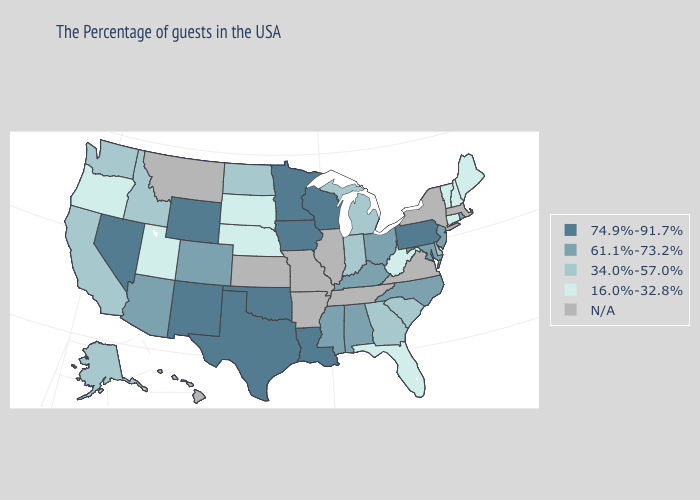Name the states that have a value in the range 61.1%-73.2%?
Answer briefly. Rhode Island, New Jersey, Maryland, North Carolina, Ohio, Kentucky, Alabama, Mississippi, Colorado, Arizona. Name the states that have a value in the range N/A?
Keep it brief. Massachusetts, New York, Virginia, Tennessee, Illinois, Missouri, Arkansas, Kansas, Montana, Hawaii. Does the first symbol in the legend represent the smallest category?
Write a very short answer. No. Does Idaho have the highest value in the West?
Give a very brief answer. No. Name the states that have a value in the range 61.1%-73.2%?
Keep it brief. Rhode Island, New Jersey, Maryland, North Carolina, Ohio, Kentucky, Alabama, Mississippi, Colorado, Arizona. Name the states that have a value in the range N/A?
Quick response, please. Massachusetts, New York, Virginia, Tennessee, Illinois, Missouri, Arkansas, Kansas, Montana, Hawaii. How many symbols are there in the legend?
Write a very short answer. 5. Which states have the lowest value in the USA?
Be succinct. Maine, New Hampshire, Vermont, Connecticut, West Virginia, Florida, Nebraska, South Dakota, Utah, Oregon. Does the map have missing data?
Give a very brief answer. Yes. Name the states that have a value in the range 74.9%-91.7%?
Quick response, please. Pennsylvania, Wisconsin, Louisiana, Minnesota, Iowa, Oklahoma, Texas, Wyoming, New Mexico, Nevada. Name the states that have a value in the range 34.0%-57.0%?
Keep it brief. Delaware, South Carolina, Georgia, Michigan, Indiana, North Dakota, Idaho, California, Washington, Alaska. Does Arizona have the highest value in the West?
Write a very short answer. No. Among the states that border Nebraska , does Iowa have the lowest value?
Quick response, please. No. 